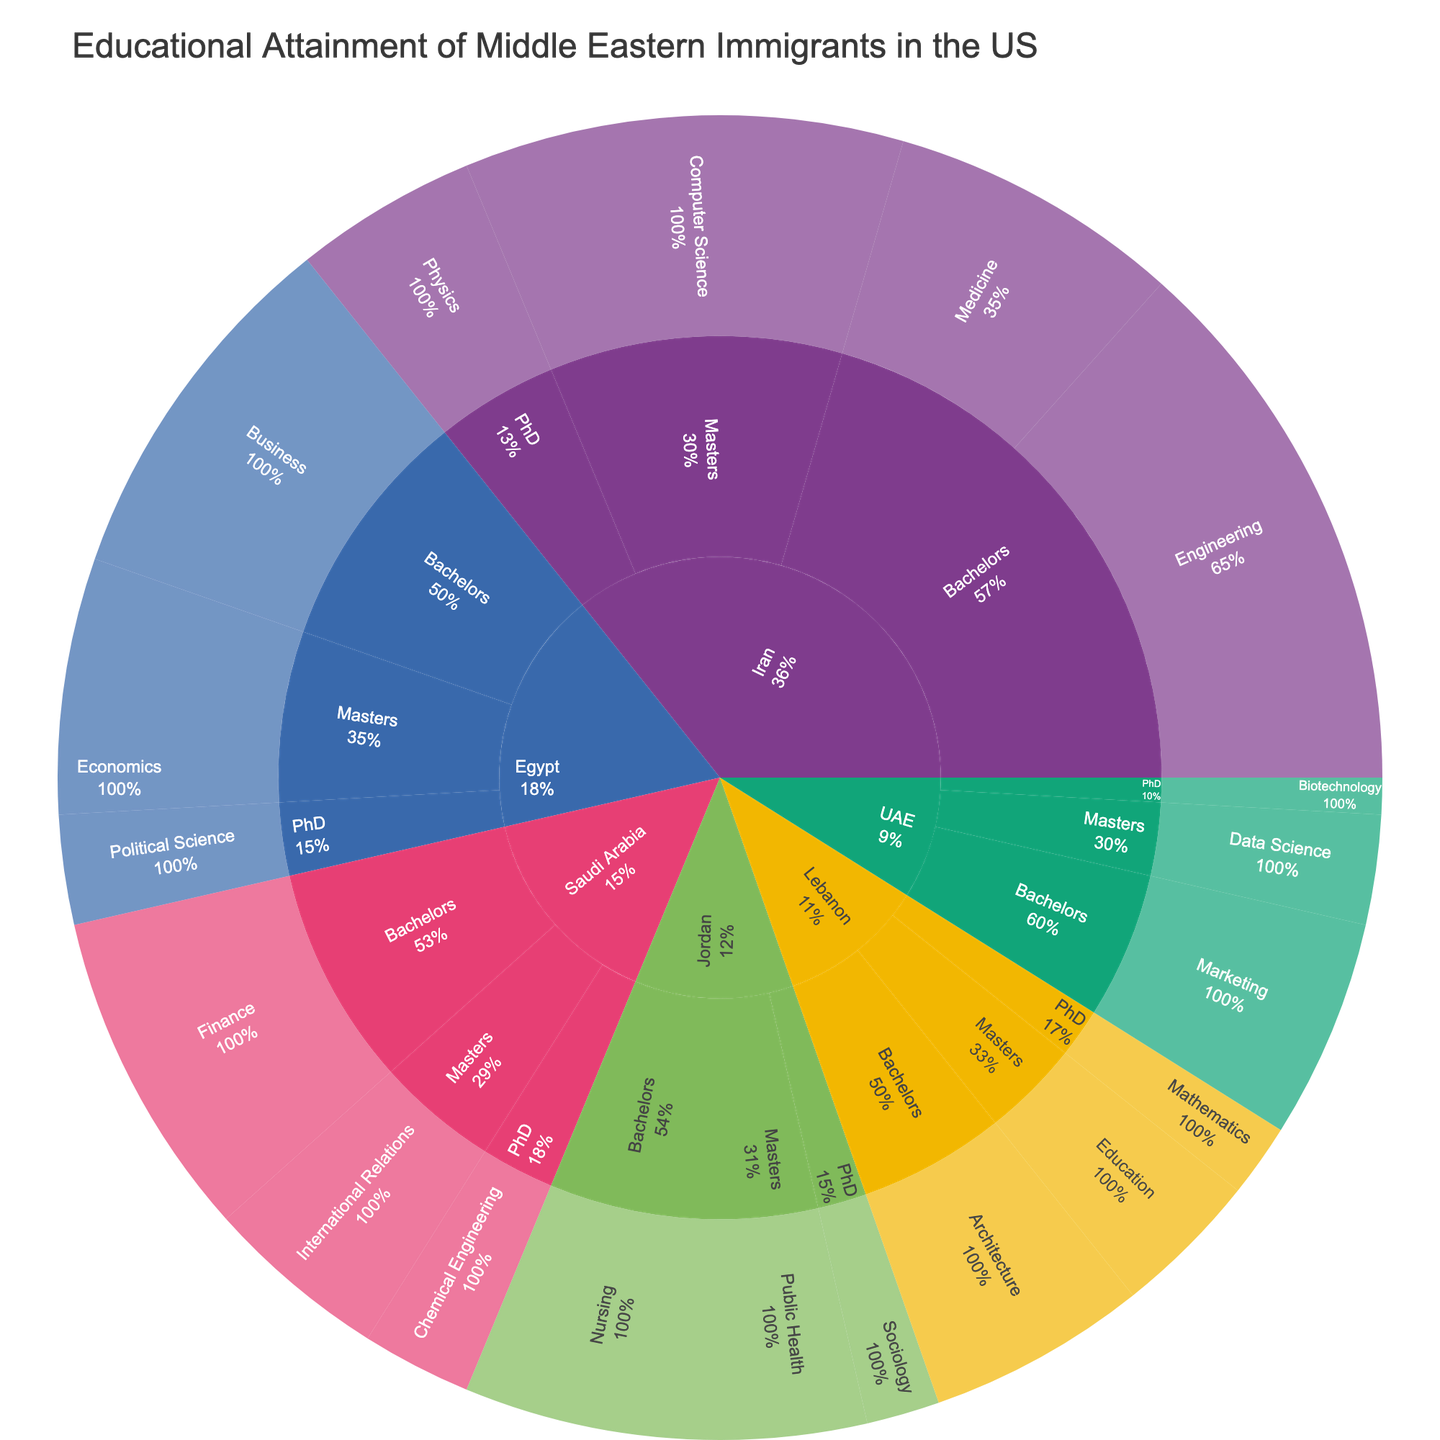What is the title of the figure? The title is usually located at the top center of the figure. It provides a summary of the content and main focus of the figure.
Answer: Educational Attainment of Middle Eastern Immigrants in the US Which country has the highest combined percentage of people in all fields of study at the Bachelor's level? Look at the outermost ring of the sunburst plot and identify the country segments. Compare the combined percentages of all fields of study at the Bachelor's level for each country.
Answer: Iran What is the percentage of Middle Eastern immigrants from Egypt with a PhD in Political Science? Locate Egypt on the sunburst plot, then follow the segments to find the education level 'PhD,' and finally the field of study 'Political Science.' The percentage will be displayed in this segment.
Answer: 3% How does the percentage of Engineering Bachelor's degree holders from Iran compare to the percentage of Finance Bachelor's degree holders from Saudi Arabia? Identify the percentages for Engineering under Bachelor's for Iran and Finance under Bachelor's for Saudi Arabia from the sunburst plot and compare them directly.
Answer: Engineering (15%) is higher than Finance (9%) Calculate the total percentage of Master's degree holders from Lebanon in all fields of study. Sum the percentages of all fields of study under the Master's category for Lebanon from the sunburst plot. Lebanon has Education (4%) under Master's.
Answer: 4% Which field of study has the lowest percentage of PhDs among Middle Eastern immigrants in the US? Compare the PhD segments for all countries and fields of study on the sunburst plot to identify the field with the lowest percentage.
Answer: Biotechnology from UAE (1%) What is the difference in percentage between Master's degree holders in Computer Science from Iran and Data Science from UAE? Find the percentages for Master's in Computer Science from Iran and Data Science from UAE on the sunburst plot and calculate the difference. Iran (12%) - UAE (3%) = 9%
Answer: 9% Which country has the most diverse fields of study at the PhD level according to this sunburst plot? Check the PhD segments for each country and count the number of different fields of study represented. The country with the most different fields under PhD is the answer.
Answer: Iran What percentage of Middle Eastern immigrants from Jordan have a degree in Nursing? Locate Jordan on the sunburst plot, then find the Bachelor's level and identify the Nursing segment to get the percentage.
Answer: 7% Compare the total percentage of PhD holders in all fields of study from Saudi Arabia and Egypt combined. Sum the percentages for all PhD fields from Saudi Arabia and Egypt. Saudi Arabia (3% Chemical Engineering) + Egypt (3% Political Science) = 6%.
Answer: 6% 